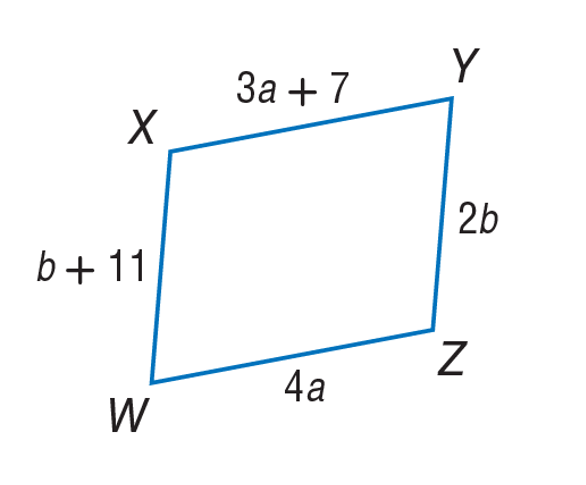Answer the mathemtical geometry problem and directly provide the correct option letter.
Question: Use parallelogram to find a.
Choices: A: 7 B: 21 C: 27 D: 28 A 